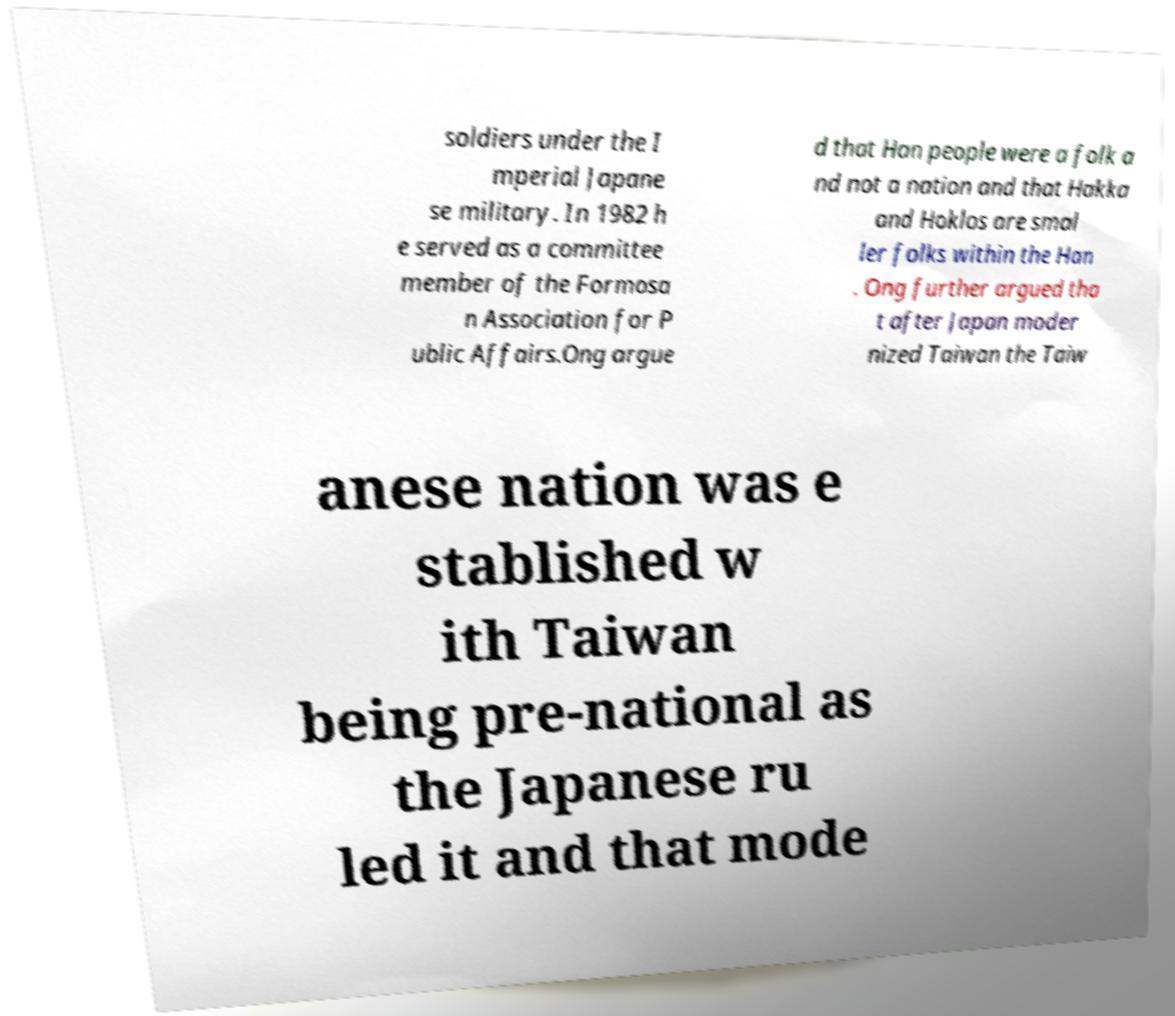For documentation purposes, I need the text within this image transcribed. Could you provide that? soldiers under the I mperial Japane se military. In 1982 h e served as a committee member of the Formosa n Association for P ublic Affairs.Ong argue d that Han people were a folk a nd not a nation and that Hakka and Hoklos are smal ler folks within the Han . Ong further argued tha t after Japan moder nized Taiwan the Taiw anese nation was e stablished w ith Taiwan being pre-national as the Japanese ru led it and that mode 